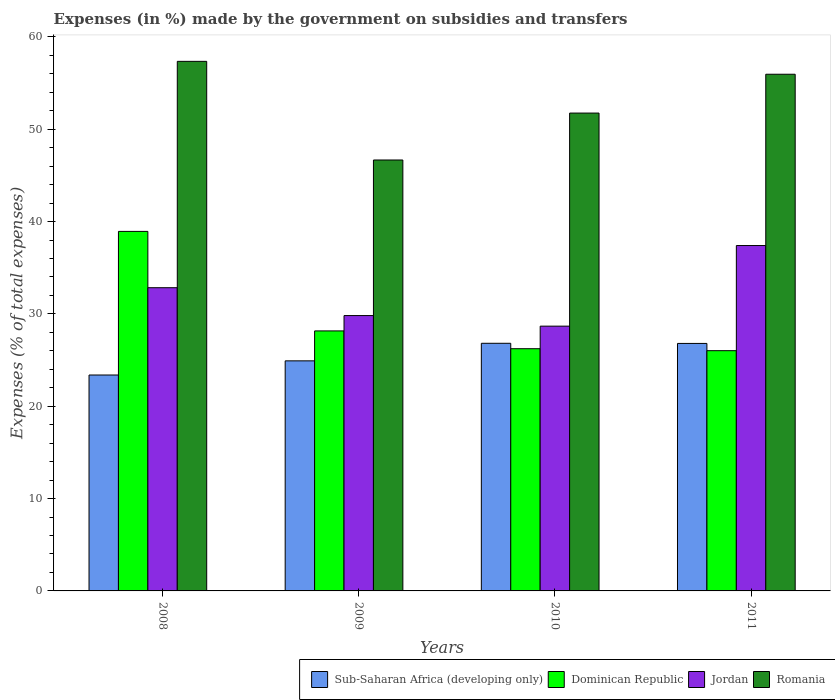How many different coloured bars are there?
Provide a succinct answer. 4. How many groups of bars are there?
Provide a short and direct response. 4. Are the number of bars per tick equal to the number of legend labels?
Offer a very short reply. Yes. What is the label of the 1st group of bars from the left?
Your answer should be compact. 2008. What is the percentage of expenses made by the government on subsidies and transfers in Dominican Republic in 2010?
Offer a very short reply. 26.23. Across all years, what is the maximum percentage of expenses made by the government on subsidies and transfers in Jordan?
Make the answer very short. 37.4. Across all years, what is the minimum percentage of expenses made by the government on subsidies and transfers in Romania?
Make the answer very short. 46.67. In which year was the percentage of expenses made by the government on subsidies and transfers in Dominican Republic maximum?
Your answer should be compact. 2008. In which year was the percentage of expenses made by the government on subsidies and transfers in Jordan minimum?
Your answer should be compact. 2010. What is the total percentage of expenses made by the government on subsidies and transfers in Sub-Saharan Africa (developing only) in the graph?
Provide a short and direct response. 101.92. What is the difference between the percentage of expenses made by the government on subsidies and transfers in Jordan in 2008 and that in 2009?
Your answer should be very brief. 3.02. What is the difference between the percentage of expenses made by the government on subsidies and transfers in Romania in 2008 and the percentage of expenses made by the government on subsidies and transfers in Dominican Republic in 2010?
Keep it short and to the point. 31.12. What is the average percentage of expenses made by the government on subsidies and transfers in Jordan per year?
Provide a succinct answer. 32.18. In the year 2009, what is the difference between the percentage of expenses made by the government on subsidies and transfers in Dominican Republic and percentage of expenses made by the government on subsidies and transfers in Sub-Saharan Africa (developing only)?
Provide a short and direct response. 3.24. In how many years, is the percentage of expenses made by the government on subsidies and transfers in Jordan greater than 58 %?
Keep it short and to the point. 0. What is the ratio of the percentage of expenses made by the government on subsidies and transfers in Romania in 2008 to that in 2009?
Offer a terse response. 1.23. Is the percentage of expenses made by the government on subsidies and transfers in Sub-Saharan Africa (developing only) in 2010 less than that in 2011?
Offer a terse response. No. What is the difference between the highest and the second highest percentage of expenses made by the government on subsidies and transfers in Sub-Saharan Africa (developing only)?
Give a very brief answer. 0.02. What is the difference between the highest and the lowest percentage of expenses made by the government on subsidies and transfers in Sub-Saharan Africa (developing only)?
Give a very brief answer. 3.44. In how many years, is the percentage of expenses made by the government on subsidies and transfers in Sub-Saharan Africa (developing only) greater than the average percentage of expenses made by the government on subsidies and transfers in Sub-Saharan Africa (developing only) taken over all years?
Make the answer very short. 2. What does the 2nd bar from the left in 2010 represents?
Provide a succinct answer. Dominican Republic. What does the 4th bar from the right in 2008 represents?
Give a very brief answer. Sub-Saharan Africa (developing only). Are all the bars in the graph horizontal?
Your answer should be very brief. No. How many years are there in the graph?
Your answer should be compact. 4. Are the values on the major ticks of Y-axis written in scientific E-notation?
Make the answer very short. No. Does the graph contain any zero values?
Make the answer very short. No. How are the legend labels stacked?
Keep it short and to the point. Horizontal. What is the title of the graph?
Ensure brevity in your answer.  Expenses (in %) made by the government on subsidies and transfers. Does "Puerto Rico" appear as one of the legend labels in the graph?
Ensure brevity in your answer.  No. What is the label or title of the Y-axis?
Provide a short and direct response. Expenses (% of total expenses). What is the Expenses (% of total expenses) in Sub-Saharan Africa (developing only) in 2008?
Your answer should be compact. 23.38. What is the Expenses (% of total expenses) in Dominican Republic in 2008?
Your answer should be compact. 38.93. What is the Expenses (% of total expenses) of Jordan in 2008?
Offer a terse response. 32.84. What is the Expenses (% of total expenses) in Romania in 2008?
Make the answer very short. 57.35. What is the Expenses (% of total expenses) of Sub-Saharan Africa (developing only) in 2009?
Keep it short and to the point. 24.91. What is the Expenses (% of total expenses) in Dominican Republic in 2009?
Ensure brevity in your answer.  28.16. What is the Expenses (% of total expenses) in Jordan in 2009?
Keep it short and to the point. 29.82. What is the Expenses (% of total expenses) in Romania in 2009?
Keep it short and to the point. 46.67. What is the Expenses (% of total expenses) in Sub-Saharan Africa (developing only) in 2010?
Offer a terse response. 26.82. What is the Expenses (% of total expenses) of Dominican Republic in 2010?
Your answer should be very brief. 26.23. What is the Expenses (% of total expenses) in Jordan in 2010?
Provide a short and direct response. 28.67. What is the Expenses (% of total expenses) in Romania in 2010?
Offer a terse response. 51.75. What is the Expenses (% of total expenses) in Sub-Saharan Africa (developing only) in 2011?
Provide a short and direct response. 26.8. What is the Expenses (% of total expenses) of Dominican Republic in 2011?
Offer a very short reply. 26.02. What is the Expenses (% of total expenses) of Jordan in 2011?
Offer a terse response. 37.4. What is the Expenses (% of total expenses) in Romania in 2011?
Provide a succinct answer. 55.95. Across all years, what is the maximum Expenses (% of total expenses) in Sub-Saharan Africa (developing only)?
Ensure brevity in your answer.  26.82. Across all years, what is the maximum Expenses (% of total expenses) of Dominican Republic?
Provide a succinct answer. 38.93. Across all years, what is the maximum Expenses (% of total expenses) of Jordan?
Keep it short and to the point. 37.4. Across all years, what is the maximum Expenses (% of total expenses) in Romania?
Make the answer very short. 57.35. Across all years, what is the minimum Expenses (% of total expenses) in Sub-Saharan Africa (developing only)?
Your answer should be very brief. 23.38. Across all years, what is the minimum Expenses (% of total expenses) in Dominican Republic?
Your answer should be very brief. 26.02. Across all years, what is the minimum Expenses (% of total expenses) of Jordan?
Your answer should be compact. 28.67. Across all years, what is the minimum Expenses (% of total expenses) of Romania?
Your answer should be very brief. 46.67. What is the total Expenses (% of total expenses) of Sub-Saharan Africa (developing only) in the graph?
Offer a terse response. 101.92. What is the total Expenses (% of total expenses) in Dominican Republic in the graph?
Your response must be concise. 119.34. What is the total Expenses (% of total expenses) of Jordan in the graph?
Provide a succinct answer. 128.73. What is the total Expenses (% of total expenses) in Romania in the graph?
Provide a succinct answer. 211.71. What is the difference between the Expenses (% of total expenses) in Sub-Saharan Africa (developing only) in 2008 and that in 2009?
Offer a very short reply. -1.53. What is the difference between the Expenses (% of total expenses) in Dominican Republic in 2008 and that in 2009?
Make the answer very short. 10.78. What is the difference between the Expenses (% of total expenses) in Jordan in 2008 and that in 2009?
Give a very brief answer. 3.02. What is the difference between the Expenses (% of total expenses) of Romania in 2008 and that in 2009?
Give a very brief answer. 10.68. What is the difference between the Expenses (% of total expenses) in Sub-Saharan Africa (developing only) in 2008 and that in 2010?
Provide a short and direct response. -3.44. What is the difference between the Expenses (% of total expenses) of Dominican Republic in 2008 and that in 2010?
Keep it short and to the point. 12.7. What is the difference between the Expenses (% of total expenses) in Jordan in 2008 and that in 2010?
Provide a short and direct response. 4.16. What is the difference between the Expenses (% of total expenses) of Romania in 2008 and that in 2010?
Your answer should be compact. 5.6. What is the difference between the Expenses (% of total expenses) of Sub-Saharan Africa (developing only) in 2008 and that in 2011?
Keep it short and to the point. -3.42. What is the difference between the Expenses (% of total expenses) in Dominican Republic in 2008 and that in 2011?
Offer a very short reply. 12.92. What is the difference between the Expenses (% of total expenses) in Jordan in 2008 and that in 2011?
Offer a very short reply. -4.57. What is the difference between the Expenses (% of total expenses) in Romania in 2008 and that in 2011?
Make the answer very short. 1.4. What is the difference between the Expenses (% of total expenses) in Sub-Saharan Africa (developing only) in 2009 and that in 2010?
Your answer should be very brief. -1.9. What is the difference between the Expenses (% of total expenses) of Dominican Republic in 2009 and that in 2010?
Offer a terse response. 1.93. What is the difference between the Expenses (% of total expenses) of Jordan in 2009 and that in 2010?
Your response must be concise. 1.14. What is the difference between the Expenses (% of total expenses) in Romania in 2009 and that in 2010?
Offer a terse response. -5.08. What is the difference between the Expenses (% of total expenses) in Sub-Saharan Africa (developing only) in 2009 and that in 2011?
Keep it short and to the point. -1.89. What is the difference between the Expenses (% of total expenses) in Dominican Republic in 2009 and that in 2011?
Keep it short and to the point. 2.14. What is the difference between the Expenses (% of total expenses) in Jordan in 2009 and that in 2011?
Give a very brief answer. -7.58. What is the difference between the Expenses (% of total expenses) of Romania in 2009 and that in 2011?
Offer a very short reply. -9.29. What is the difference between the Expenses (% of total expenses) in Sub-Saharan Africa (developing only) in 2010 and that in 2011?
Offer a terse response. 0.02. What is the difference between the Expenses (% of total expenses) of Dominican Republic in 2010 and that in 2011?
Make the answer very short. 0.21. What is the difference between the Expenses (% of total expenses) in Jordan in 2010 and that in 2011?
Ensure brevity in your answer.  -8.73. What is the difference between the Expenses (% of total expenses) in Romania in 2010 and that in 2011?
Your answer should be very brief. -4.2. What is the difference between the Expenses (% of total expenses) in Sub-Saharan Africa (developing only) in 2008 and the Expenses (% of total expenses) in Dominican Republic in 2009?
Give a very brief answer. -4.77. What is the difference between the Expenses (% of total expenses) of Sub-Saharan Africa (developing only) in 2008 and the Expenses (% of total expenses) of Jordan in 2009?
Make the answer very short. -6.44. What is the difference between the Expenses (% of total expenses) of Sub-Saharan Africa (developing only) in 2008 and the Expenses (% of total expenses) of Romania in 2009?
Your answer should be very brief. -23.28. What is the difference between the Expenses (% of total expenses) of Dominican Republic in 2008 and the Expenses (% of total expenses) of Jordan in 2009?
Make the answer very short. 9.12. What is the difference between the Expenses (% of total expenses) of Dominican Republic in 2008 and the Expenses (% of total expenses) of Romania in 2009?
Provide a short and direct response. -7.73. What is the difference between the Expenses (% of total expenses) of Jordan in 2008 and the Expenses (% of total expenses) of Romania in 2009?
Provide a short and direct response. -13.83. What is the difference between the Expenses (% of total expenses) in Sub-Saharan Africa (developing only) in 2008 and the Expenses (% of total expenses) in Dominican Republic in 2010?
Give a very brief answer. -2.85. What is the difference between the Expenses (% of total expenses) in Sub-Saharan Africa (developing only) in 2008 and the Expenses (% of total expenses) in Jordan in 2010?
Ensure brevity in your answer.  -5.29. What is the difference between the Expenses (% of total expenses) of Sub-Saharan Africa (developing only) in 2008 and the Expenses (% of total expenses) of Romania in 2010?
Your response must be concise. -28.37. What is the difference between the Expenses (% of total expenses) of Dominican Republic in 2008 and the Expenses (% of total expenses) of Jordan in 2010?
Your response must be concise. 10.26. What is the difference between the Expenses (% of total expenses) of Dominican Republic in 2008 and the Expenses (% of total expenses) of Romania in 2010?
Give a very brief answer. -12.82. What is the difference between the Expenses (% of total expenses) of Jordan in 2008 and the Expenses (% of total expenses) of Romania in 2010?
Give a very brief answer. -18.91. What is the difference between the Expenses (% of total expenses) of Sub-Saharan Africa (developing only) in 2008 and the Expenses (% of total expenses) of Dominican Republic in 2011?
Give a very brief answer. -2.63. What is the difference between the Expenses (% of total expenses) of Sub-Saharan Africa (developing only) in 2008 and the Expenses (% of total expenses) of Jordan in 2011?
Keep it short and to the point. -14.02. What is the difference between the Expenses (% of total expenses) of Sub-Saharan Africa (developing only) in 2008 and the Expenses (% of total expenses) of Romania in 2011?
Your answer should be very brief. -32.57. What is the difference between the Expenses (% of total expenses) in Dominican Republic in 2008 and the Expenses (% of total expenses) in Jordan in 2011?
Ensure brevity in your answer.  1.53. What is the difference between the Expenses (% of total expenses) of Dominican Republic in 2008 and the Expenses (% of total expenses) of Romania in 2011?
Your response must be concise. -17.02. What is the difference between the Expenses (% of total expenses) of Jordan in 2008 and the Expenses (% of total expenses) of Romania in 2011?
Your answer should be very brief. -23.12. What is the difference between the Expenses (% of total expenses) in Sub-Saharan Africa (developing only) in 2009 and the Expenses (% of total expenses) in Dominican Republic in 2010?
Provide a short and direct response. -1.31. What is the difference between the Expenses (% of total expenses) in Sub-Saharan Africa (developing only) in 2009 and the Expenses (% of total expenses) in Jordan in 2010?
Ensure brevity in your answer.  -3.76. What is the difference between the Expenses (% of total expenses) of Sub-Saharan Africa (developing only) in 2009 and the Expenses (% of total expenses) of Romania in 2010?
Provide a short and direct response. -26.83. What is the difference between the Expenses (% of total expenses) in Dominican Republic in 2009 and the Expenses (% of total expenses) in Jordan in 2010?
Give a very brief answer. -0.52. What is the difference between the Expenses (% of total expenses) of Dominican Republic in 2009 and the Expenses (% of total expenses) of Romania in 2010?
Make the answer very short. -23.59. What is the difference between the Expenses (% of total expenses) of Jordan in 2009 and the Expenses (% of total expenses) of Romania in 2010?
Make the answer very short. -21.93. What is the difference between the Expenses (% of total expenses) of Sub-Saharan Africa (developing only) in 2009 and the Expenses (% of total expenses) of Dominican Republic in 2011?
Your answer should be compact. -1.1. What is the difference between the Expenses (% of total expenses) of Sub-Saharan Africa (developing only) in 2009 and the Expenses (% of total expenses) of Jordan in 2011?
Offer a terse response. -12.49. What is the difference between the Expenses (% of total expenses) of Sub-Saharan Africa (developing only) in 2009 and the Expenses (% of total expenses) of Romania in 2011?
Offer a terse response. -31.04. What is the difference between the Expenses (% of total expenses) of Dominican Republic in 2009 and the Expenses (% of total expenses) of Jordan in 2011?
Your answer should be very brief. -9.25. What is the difference between the Expenses (% of total expenses) of Dominican Republic in 2009 and the Expenses (% of total expenses) of Romania in 2011?
Offer a very short reply. -27.8. What is the difference between the Expenses (% of total expenses) in Jordan in 2009 and the Expenses (% of total expenses) in Romania in 2011?
Provide a succinct answer. -26.13. What is the difference between the Expenses (% of total expenses) of Sub-Saharan Africa (developing only) in 2010 and the Expenses (% of total expenses) of Dominican Republic in 2011?
Your answer should be very brief. 0.8. What is the difference between the Expenses (% of total expenses) of Sub-Saharan Africa (developing only) in 2010 and the Expenses (% of total expenses) of Jordan in 2011?
Provide a succinct answer. -10.58. What is the difference between the Expenses (% of total expenses) of Sub-Saharan Africa (developing only) in 2010 and the Expenses (% of total expenses) of Romania in 2011?
Provide a short and direct response. -29.13. What is the difference between the Expenses (% of total expenses) in Dominican Republic in 2010 and the Expenses (% of total expenses) in Jordan in 2011?
Give a very brief answer. -11.17. What is the difference between the Expenses (% of total expenses) in Dominican Republic in 2010 and the Expenses (% of total expenses) in Romania in 2011?
Your response must be concise. -29.72. What is the difference between the Expenses (% of total expenses) in Jordan in 2010 and the Expenses (% of total expenses) in Romania in 2011?
Your answer should be very brief. -27.28. What is the average Expenses (% of total expenses) in Sub-Saharan Africa (developing only) per year?
Your response must be concise. 25.48. What is the average Expenses (% of total expenses) in Dominican Republic per year?
Provide a succinct answer. 29.83. What is the average Expenses (% of total expenses) in Jordan per year?
Provide a short and direct response. 32.18. What is the average Expenses (% of total expenses) of Romania per year?
Keep it short and to the point. 52.93. In the year 2008, what is the difference between the Expenses (% of total expenses) of Sub-Saharan Africa (developing only) and Expenses (% of total expenses) of Dominican Republic?
Provide a short and direct response. -15.55. In the year 2008, what is the difference between the Expenses (% of total expenses) of Sub-Saharan Africa (developing only) and Expenses (% of total expenses) of Jordan?
Offer a very short reply. -9.45. In the year 2008, what is the difference between the Expenses (% of total expenses) of Sub-Saharan Africa (developing only) and Expenses (% of total expenses) of Romania?
Your answer should be very brief. -33.97. In the year 2008, what is the difference between the Expenses (% of total expenses) in Dominican Republic and Expenses (% of total expenses) in Jordan?
Provide a succinct answer. 6.1. In the year 2008, what is the difference between the Expenses (% of total expenses) of Dominican Republic and Expenses (% of total expenses) of Romania?
Your answer should be very brief. -18.41. In the year 2008, what is the difference between the Expenses (% of total expenses) in Jordan and Expenses (% of total expenses) in Romania?
Provide a succinct answer. -24.51. In the year 2009, what is the difference between the Expenses (% of total expenses) of Sub-Saharan Africa (developing only) and Expenses (% of total expenses) of Dominican Republic?
Keep it short and to the point. -3.24. In the year 2009, what is the difference between the Expenses (% of total expenses) in Sub-Saharan Africa (developing only) and Expenses (% of total expenses) in Jordan?
Your response must be concise. -4.9. In the year 2009, what is the difference between the Expenses (% of total expenses) in Sub-Saharan Africa (developing only) and Expenses (% of total expenses) in Romania?
Provide a succinct answer. -21.75. In the year 2009, what is the difference between the Expenses (% of total expenses) of Dominican Republic and Expenses (% of total expenses) of Jordan?
Provide a succinct answer. -1.66. In the year 2009, what is the difference between the Expenses (% of total expenses) of Dominican Republic and Expenses (% of total expenses) of Romania?
Give a very brief answer. -18.51. In the year 2009, what is the difference between the Expenses (% of total expenses) in Jordan and Expenses (% of total expenses) in Romania?
Your answer should be very brief. -16.85. In the year 2010, what is the difference between the Expenses (% of total expenses) of Sub-Saharan Africa (developing only) and Expenses (% of total expenses) of Dominican Republic?
Your answer should be very brief. 0.59. In the year 2010, what is the difference between the Expenses (% of total expenses) in Sub-Saharan Africa (developing only) and Expenses (% of total expenses) in Jordan?
Your response must be concise. -1.86. In the year 2010, what is the difference between the Expenses (% of total expenses) in Sub-Saharan Africa (developing only) and Expenses (% of total expenses) in Romania?
Offer a terse response. -24.93. In the year 2010, what is the difference between the Expenses (% of total expenses) of Dominican Republic and Expenses (% of total expenses) of Jordan?
Ensure brevity in your answer.  -2.44. In the year 2010, what is the difference between the Expenses (% of total expenses) of Dominican Republic and Expenses (% of total expenses) of Romania?
Give a very brief answer. -25.52. In the year 2010, what is the difference between the Expenses (% of total expenses) of Jordan and Expenses (% of total expenses) of Romania?
Provide a short and direct response. -23.08. In the year 2011, what is the difference between the Expenses (% of total expenses) in Sub-Saharan Africa (developing only) and Expenses (% of total expenses) in Dominican Republic?
Offer a very short reply. 0.79. In the year 2011, what is the difference between the Expenses (% of total expenses) in Sub-Saharan Africa (developing only) and Expenses (% of total expenses) in Jordan?
Make the answer very short. -10.6. In the year 2011, what is the difference between the Expenses (% of total expenses) of Sub-Saharan Africa (developing only) and Expenses (% of total expenses) of Romania?
Ensure brevity in your answer.  -29.15. In the year 2011, what is the difference between the Expenses (% of total expenses) of Dominican Republic and Expenses (% of total expenses) of Jordan?
Your response must be concise. -11.39. In the year 2011, what is the difference between the Expenses (% of total expenses) in Dominican Republic and Expenses (% of total expenses) in Romania?
Keep it short and to the point. -29.94. In the year 2011, what is the difference between the Expenses (% of total expenses) in Jordan and Expenses (% of total expenses) in Romania?
Offer a terse response. -18.55. What is the ratio of the Expenses (% of total expenses) of Sub-Saharan Africa (developing only) in 2008 to that in 2009?
Keep it short and to the point. 0.94. What is the ratio of the Expenses (% of total expenses) of Dominican Republic in 2008 to that in 2009?
Make the answer very short. 1.38. What is the ratio of the Expenses (% of total expenses) of Jordan in 2008 to that in 2009?
Ensure brevity in your answer.  1.1. What is the ratio of the Expenses (% of total expenses) in Romania in 2008 to that in 2009?
Provide a short and direct response. 1.23. What is the ratio of the Expenses (% of total expenses) in Sub-Saharan Africa (developing only) in 2008 to that in 2010?
Offer a very short reply. 0.87. What is the ratio of the Expenses (% of total expenses) of Dominican Republic in 2008 to that in 2010?
Provide a succinct answer. 1.48. What is the ratio of the Expenses (% of total expenses) in Jordan in 2008 to that in 2010?
Offer a terse response. 1.15. What is the ratio of the Expenses (% of total expenses) in Romania in 2008 to that in 2010?
Provide a succinct answer. 1.11. What is the ratio of the Expenses (% of total expenses) in Sub-Saharan Africa (developing only) in 2008 to that in 2011?
Your answer should be very brief. 0.87. What is the ratio of the Expenses (% of total expenses) of Dominican Republic in 2008 to that in 2011?
Make the answer very short. 1.5. What is the ratio of the Expenses (% of total expenses) of Jordan in 2008 to that in 2011?
Make the answer very short. 0.88. What is the ratio of the Expenses (% of total expenses) in Sub-Saharan Africa (developing only) in 2009 to that in 2010?
Offer a very short reply. 0.93. What is the ratio of the Expenses (% of total expenses) of Dominican Republic in 2009 to that in 2010?
Keep it short and to the point. 1.07. What is the ratio of the Expenses (% of total expenses) in Jordan in 2009 to that in 2010?
Keep it short and to the point. 1.04. What is the ratio of the Expenses (% of total expenses) of Romania in 2009 to that in 2010?
Offer a very short reply. 0.9. What is the ratio of the Expenses (% of total expenses) in Sub-Saharan Africa (developing only) in 2009 to that in 2011?
Provide a succinct answer. 0.93. What is the ratio of the Expenses (% of total expenses) in Dominican Republic in 2009 to that in 2011?
Keep it short and to the point. 1.08. What is the ratio of the Expenses (% of total expenses) in Jordan in 2009 to that in 2011?
Provide a short and direct response. 0.8. What is the ratio of the Expenses (% of total expenses) in Romania in 2009 to that in 2011?
Give a very brief answer. 0.83. What is the ratio of the Expenses (% of total expenses) in Dominican Republic in 2010 to that in 2011?
Provide a short and direct response. 1.01. What is the ratio of the Expenses (% of total expenses) of Jordan in 2010 to that in 2011?
Provide a succinct answer. 0.77. What is the ratio of the Expenses (% of total expenses) of Romania in 2010 to that in 2011?
Keep it short and to the point. 0.92. What is the difference between the highest and the second highest Expenses (% of total expenses) of Sub-Saharan Africa (developing only)?
Keep it short and to the point. 0.02. What is the difference between the highest and the second highest Expenses (% of total expenses) of Dominican Republic?
Your answer should be very brief. 10.78. What is the difference between the highest and the second highest Expenses (% of total expenses) of Jordan?
Provide a short and direct response. 4.57. What is the difference between the highest and the second highest Expenses (% of total expenses) in Romania?
Make the answer very short. 1.4. What is the difference between the highest and the lowest Expenses (% of total expenses) in Sub-Saharan Africa (developing only)?
Give a very brief answer. 3.44. What is the difference between the highest and the lowest Expenses (% of total expenses) in Dominican Republic?
Your response must be concise. 12.92. What is the difference between the highest and the lowest Expenses (% of total expenses) in Jordan?
Your answer should be very brief. 8.73. What is the difference between the highest and the lowest Expenses (% of total expenses) of Romania?
Provide a succinct answer. 10.68. 